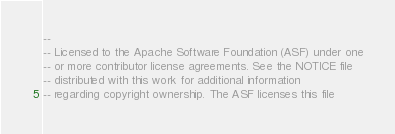Convert code to text. <code><loc_0><loc_0><loc_500><loc_500><_SQL_>--
-- Licensed to the Apache Software Foundation (ASF) under one
-- or more contributor license agreements. See the NOTICE file
-- distributed with this work for additional information
-- regarding copyright ownership. The ASF licenses this file</code> 